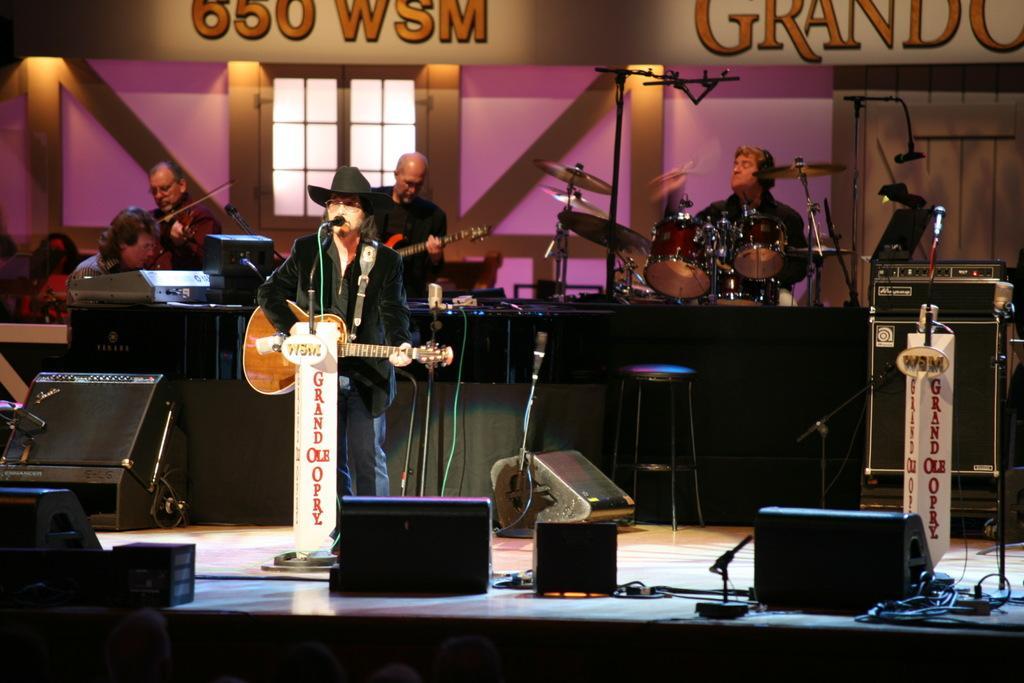Describe this image in one or two sentences. Front this person is playing guitar and singing in-front of mic wore hat. Far this four persons are playing musical instruments. On this stage we can able to see chair, mic, speaker and devices. 